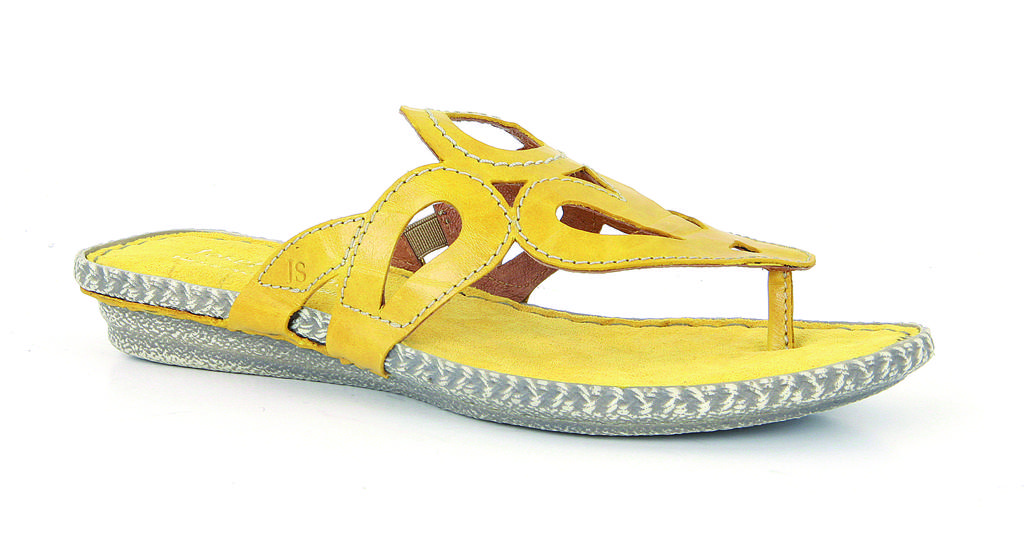What type of footwear is present in the image? There is a slipper in the image. Can you describe the slipper in more detail? Unfortunately, the image does not provide enough detail to describe the slipper further. What type of kite is being washed in the image? There is no kite or washing activity present in the image; it only features a slipper. 